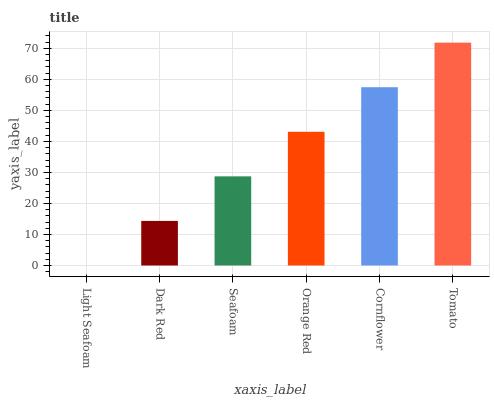Is Light Seafoam the minimum?
Answer yes or no. Yes. Is Tomato the maximum?
Answer yes or no. Yes. Is Dark Red the minimum?
Answer yes or no. No. Is Dark Red the maximum?
Answer yes or no. No. Is Dark Red greater than Light Seafoam?
Answer yes or no. Yes. Is Light Seafoam less than Dark Red?
Answer yes or no. Yes. Is Light Seafoam greater than Dark Red?
Answer yes or no. No. Is Dark Red less than Light Seafoam?
Answer yes or no. No. Is Orange Red the high median?
Answer yes or no. Yes. Is Seafoam the low median?
Answer yes or no. Yes. Is Dark Red the high median?
Answer yes or no. No. Is Orange Red the low median?
Answer yes or no. No. 